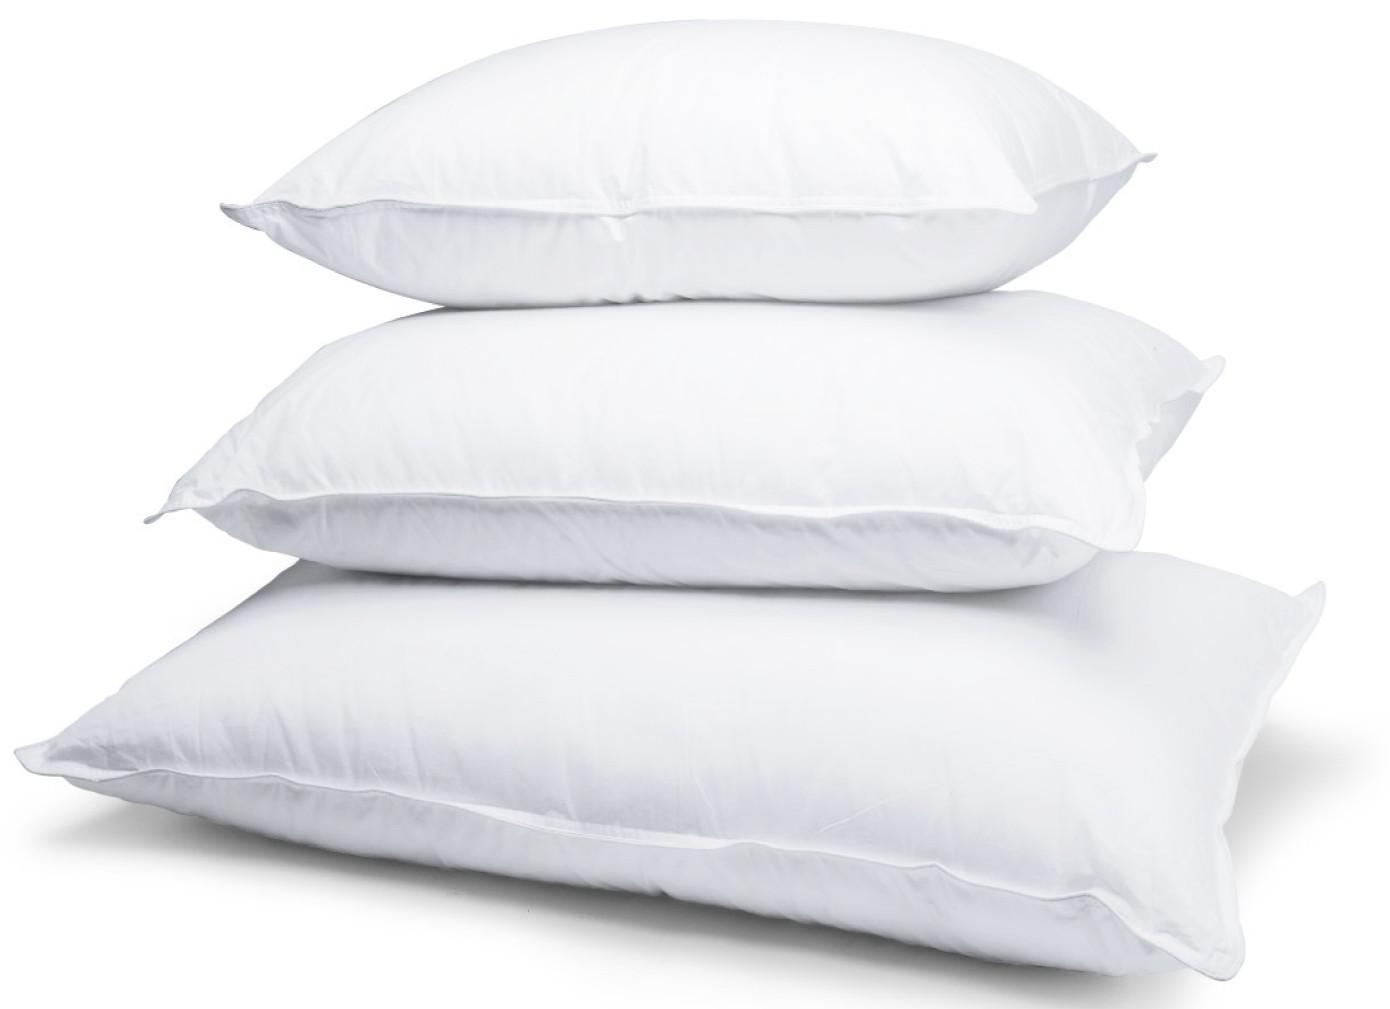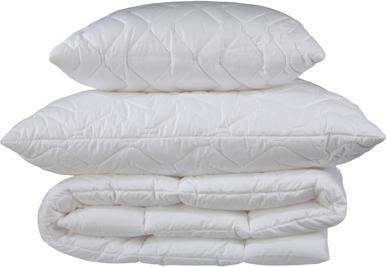The first image is the image on the left, the second image is the image on the right. Considering the images on both sides, is "There are four pillows stacked up in the image on the left." valid? Answer yes or no. No. 